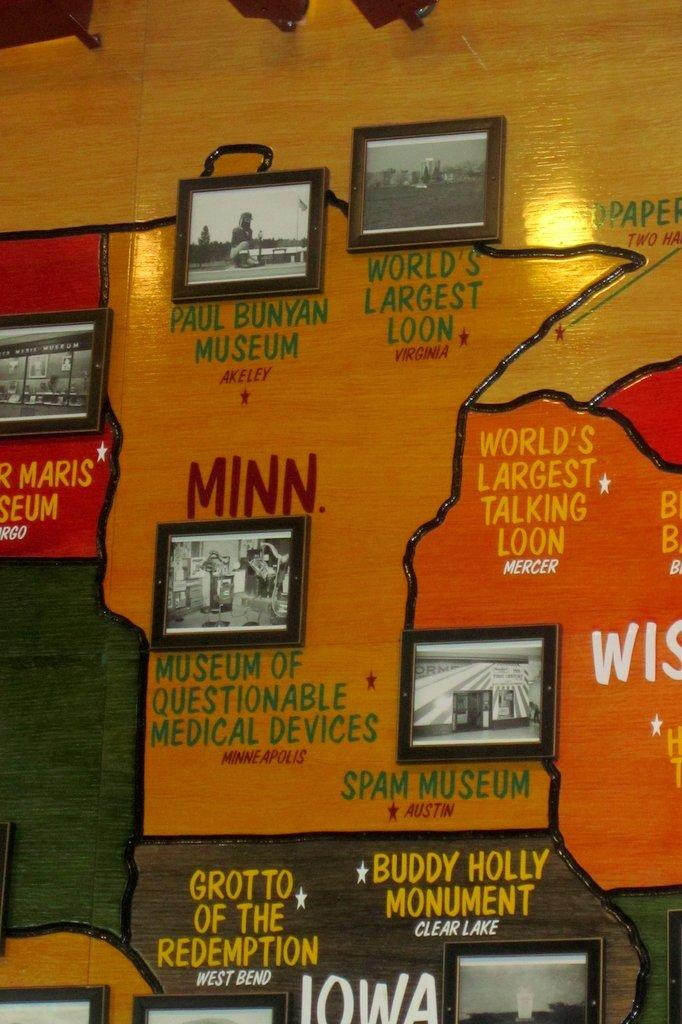<image>
Share a concise interpretation of the image provided. A sign that is for Minnesota with pictures of the Paul Bunyan Museum, World's Largest Loon, Museum of Questionable Medical Devices, and Spam Museum. 